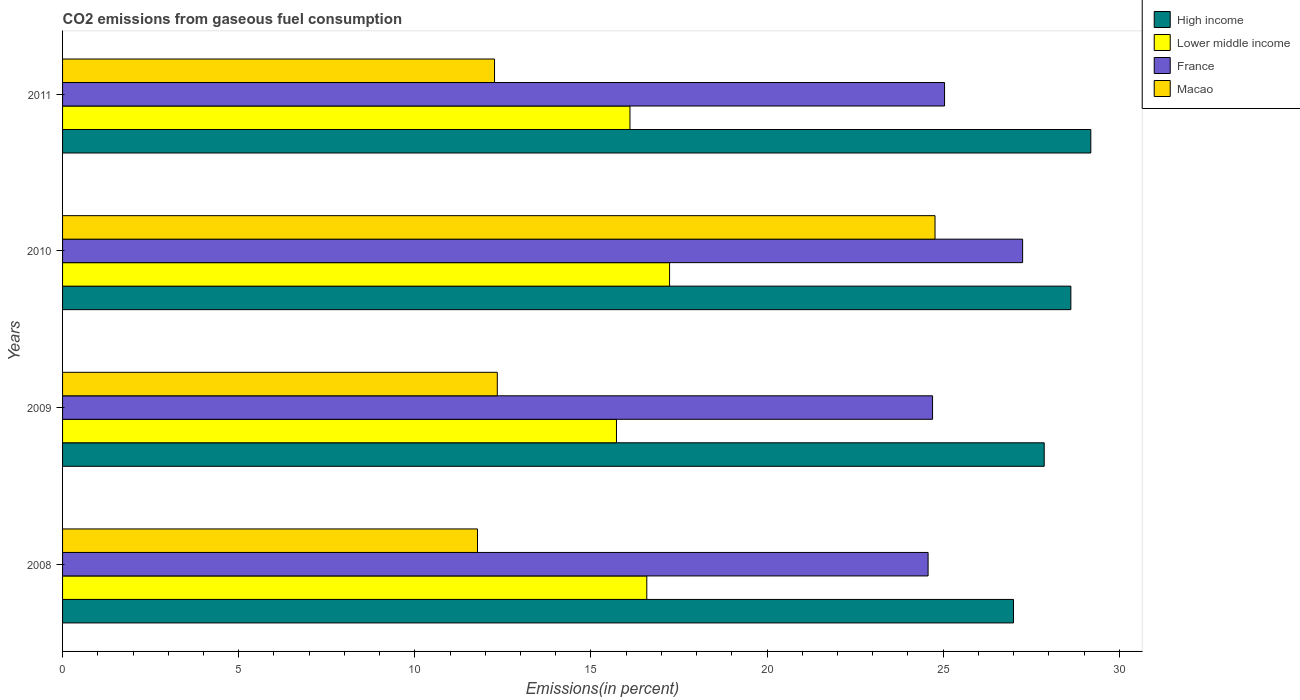How many different coloured bars are there?
Ensure brevity in your answer.  4. How many groups of bars are there?
Provide a succinct answer. 4. Are the number of bars on each tick of the Y-axis equal?
Your response must be concise. Yes. How many bars are there on the 1st tick from the bottom?
Your response must be concise. 4. What is the total CO2 emitted in Lower middle income in 2011?
Ensure brevity in your answer.  16.11. Across all years, what is the maximum total CO2 emitted in France?
Provide a succinct answer. 27.26. Across all years, what is the minimum total CO2 emitted in Lower middle income?
Your answer should be very brief. 15.73. In which year was the total CO2 emitted in High income maximum?
Provide a short and direct response. 2011. In which year was the total CO2 emitted in France minimum?
Make the answer very short. 2008. What is the total total CO2 emitted in France in the graph?
Make the answer very short. 101.57. What is the difference between the total CO2 emitted in France in 2008 and that in 2011?
Keep it short and to the point. -0.47. What is the difference between the total CO2 emitted in Macao in 2009 and the total CO2 emitted in Lower middle income in 2008?
Give a very brief answer. -4.24. What is the average total CO2 emitted in Macao per year?
Your answer should be compact. 15.29. In the year 2008, what is the difference between the total CO2 emitted in France and total CO2 emitted in Lower middle income?
Your answer should be very brief. 7.99. What is the ratio of the total CO2 emitted in Macao in 2010 to that in 2011?
Ensure brevity in your answer.  2.02. Is the total CO2 emitted in Macao in 2009 less than that in 2010?
Provide a short and direct response. Yes. Is the difference between the total CO2 emitted in France in 2009 and 2011 greater than the difference between the total CO2 emitted in Lower middle income in 2009 and 2011?
Your answer should be very brief. Yes. What is the difference between the highest and the second highest total CO2 emitted in Lower middle income?
Provide a succinct answer. 0.65. What is the difference between the highest and the lowest total CO2 emitted in Lower middle income?
Offer a very short reply. 1.51. In how many years, is the total CO2 emitted in High income greater than the average total CO2 emitted in High income taken over all years?
Offer a very short reply. 2. Is it the case that in every year, the sum of the total CO2 emitted in High income and total CO2 emitted in Macao is greater than the sum of total CO2 emitted in France and total CO2 emitted in Lower middle income?
Your response must be concise. Yes. What does the 2nd bar from the top in 2008 represents?
Your answer should be compact. France. What does the 1st bar from the bottom in 2011 represents?
Offer a very short reply. High income. How many bars are there?
Provide a short and direct response. 16. Are all the bars in the graph horizontal?
Keep it short and to the point. Yes. Does the graph contain any zero values?
Provide a short and direct response. No. Does the graph contain grids?
Your answer should be compact. No. Where does the legend appear in the graph?
Provide a short and direct response. Top right. How are the legend labels stacked?
Offer a very short reply. Vertical. What is the title of the graph?
Offer a very short reply. CO2 emissions from gaseous fuel consumption. Does "Georgia" appear as one of the legend labels in the graph?
Your answer should be very brief. No. What is the label or title of the X-axis?
Your answer should be compact. Emissions(in percent). What is the Emissions(in percent) in High income in 2008?
Ensure brevity in your answer.  27. What is the Emissions(in percent) of Lower middle income in 2008?
Ensure brevity in your answer.  16.59. What is the Emissions(in percent) in France in 2008?
Provide a succinct answer. 24.57. What is the Emissions(in percent) of Macao in 2008?
Ensure brevity in your answer.  11.78. What is the Emissions(in percent) of High income in 2009?
Provide a succinct answer. 27.87. What is the Emissions(in percent) of Lower middle income in 2009?
Ensure brevity in your answer.  15.73. What is the Emissions(in percent) of France in 2009?
Your response must be concise. 24.7. What is the Emissions(in percent) in Macao in 2009?
Offer a very short reply. 12.34. What is the Emissions(in percent) of High income in 2010?
Ensure brevity in your answer.  28.63. What is the Emissions(in percent) of Lower middle income in 2010?
Give a very brief answer. 17.23. What is the Emissions(in percent) in France in 2010?
Provide a short and direct response. 27.26. What is the Emissions(in percent) of Macao in 2010?
Ensure brevity in your answer.  24.77. What is the Emissions(in percent) of High income in 2011?
Provide a short and direct response. 29.19. What is the Emissions(in percent) in Lower middle income in 2011?
Your answer should be very brief. 16.11. What is the Emissions(in percent) of France in 2011?
Ensure brevity in your answer.  25.04. What is the Emissions(in percent) of Macao in 2011?
Ensure brevity in your answer.  12.26. Across all years, what is the maximum Emissions(in percent) of High income?
Offer a very short reply. 29.19. Across all years, what is the maximum Emissions(in percent) in Lower middle income?
Provide a succinct answer. 17.23. Across all years, what is the maximum Emissions(in percent) in France?
Your answer should be very brief. 27.26. Across all years, what is the maximum Emissions(in percent) in Macao?
Offer a very short reply. 24.77. Across all years, what is the minimum Emissions(in percent) in High income?
Provide a succinct answer. 27. Across all years, what is the minimum Emissions(in percent) of Lower middle income?
Offer a very short reply. 15.73. Across all years, what is the minimum Emissions(in percent) of France?
Offer a very short reply. 24.57. Across all years, what is the minimum Emissions(in percent) in Macao?
Give a very brief answer. 11.78. What is the total Emissions(in percent) of High income in the graph?
Give a very brief answer. 112.69. What is the total Emissions(in percent) in Lower middle income in the graph?
Provide a short and direct response. 65.66. What is the total Emissions(in percent) of France in the graph?
Offer a terse response. 101.57. What is the total Emissions(in percent) in Macao in the graph?
Offer a terse response. 61.16. What is the difference between the Emissions(in percent) in High income in 2008 and that in 2009?
Your response must be concise. -0.87. What is the difference between the Emissions(in percent) of Lower middle income in 2008 and that in 2009?
Your answer should be very brief. 0.86. What is the difference between the Emissions(in percent) in France in 2008 and that in 2009?
Your answer should be very brief. -0.13. What is the difference between the Emissions(in percent) of Macao in 2008 and that in 2009?
Your answer should be very brief. -0.56. What is the difference between the Emissions(in percent) in High income in 2008 and that in 2010?
Your response must be concise. -1.63. What is the difference between the Emissions(in percent) in Lower middle income in 2008 and that in 2010?
Your answer should be compact. -0.65. What is the difference between the Emissions(in percent) of France in 2008 and that in 2010?
Your answer should be compact. -2.68. What is the difference between the Emissions(in percent) in Macao in 2008 and that in 2010?
Offer a very short reply. -12.99. What is the difference between the Emissions(in percent) of High income in 2008 and that in 2011?
Make the answer very short. -2.19. What is the difference between the Emissions(in percent) in Lower middle income in 2008 and that in 2011?
Provide a succinct answer. 0.48. What is the difference between the Emissions(in percent) in France in 2008 and that in 2011?
Offer a terse response. -0.47. What is the difference between the Emissions(in percent) in Macao in 2008 and that in 2011?
Your answer should be very brief. -0.48. What is the difference between the Emissions(in percent) of High income in 2009 and that in 2010?
Provide a succinct answer. -0.76. What is the difference between the Emissions(in percent) in Lower middle income in 2009 and that in 2010?
Make the answer very short. -1.51. What is the difference between the Emissions(in percent) of France in 2009 and that in 2010?
Give a very brief answer. -2.56. What is the difference between the Emissions(in percent) in Macao in 2009 and that in 2010?
Your answer should be very brief. -12.43. What is the difference between the Emissions(in percent) of High income in 2009 and that in 2011?
Make the answer very short. -1.32. What is the difference between the Emissions(in percent) of Lower middle income in 2009 and that in 2011?
Provide a short and direct response. -0.38. What is the difference between the Emissions(in percent) of France in 2009 and that in 2011?
Your response must be concise. -0.34. What is the difference between the Emissions(in percent) in Macao in 2009 and that in 2011?
Keep it short and to the point. 0.08. What is the difference between the Emissions(in percent) of High income in 2010 and that in 2011?
Offer a terse response. -0.57. What is the difference between the Emissions(in percent) of Lower middle income in 2010 and that in 2011?
Offer a terse response. 1.12. What is the difference between the Emissions(in percent) in France in 2010 and that in 2011?
Your answer should be very brief. 2.22. What is the difference between the Emissions(in percent) of Macao in 2010 and that in 2011?
Provide a short and direct response. 12.51. What is the difference between the Emissions(in percent) of High income in 2008 and the Emissions(in percent) of Lower middle income in 2009?
Offer a very short reply. 11.27. What is the difference between the Emissions(in percent) of High income in 2008 and the Emissions(in percent) of France in 2009?
Your response must be concise. 2.3. What is the difference between the Emissions(in percent) of High income in 2008 and the Emissions(in percent) of Macao in 2009?
Make the answer very short. 14.66. What is the difference between the Emissions(in percent) in Lower middle income in 2008 and the Emissions(in percent) in France in 2009?
Your answer should be compact. -8.11. What is the difference between the Emissions(in percent) in Lower middle income in 2008 and the Emissions(in percent) in Macao in 2009?
Provide a short and direct response. 4.24. What is the difference between the Emissions(in percent) in France in 2008 and the Emissions(in percent) in Macao in 2009?
Make the answer very short. 12.23. What is the difference between the Emissions(in percent) of High income in 2008 and the Emissions(in percent) of Lower middle income in 2010?
Your answer should be very brief. 9.76. What is the difference between the Emissions(in percent) of High income in 2008 and the Emissions(in percent) of France in 2010?
Provide a succinct answer. -0.26. What is the difference between the Emissions(in percent) in High income in 2008 and the Emissions(in percent) in Macao in 2010?
Offer a very short reply. 2.23. What is the difference between the Emissions(in percent) in Lower middle income in 2008 and the Emissions(in percent) in France in 2010?
Make the answer very short. -10.67. What is the difference between the Emissions(in percent) in Lower middle income in 2008 and the Emissions(in percent) in Macao in 2010?
Provide a succinct answer. -8.18. What is the difference between the Emissions(in percent) in France in 2008 and the Emissions(in percent) in Macao in 2010?
Give a very brief answer. -0.2. What is the difference between the Emissions(in percent) of High income in 2008 and the Emissions(in percent) of Lower middle income in 2011?
Ensure brevity in your answer.  10.89. What is the difference between the Emissions(in percent) of High income in 2008 and the Emissions(in percent) of France in 2011?
Offer a terse response. 1.96. What is the difference between the Emissions(in percent) in High income in 2008 and the Emissions(in percent) in Macao in 2011?
Provide a short and direct response. 14.73. What is the difference between the Emissions(in percent) of Lower middle income in 2008 and the Emissions(in percent) of France in 2011?
Provide a succinct answer. -8.45. What is the difference between the Emissions(in percent) in Lower middle income in 2008 and the Emissions(in percent) in Macao in 2011?
Offer a very short reply. 4.32. What is the difference between the Emissions(in percent) of France in 2008 and the Emissions(in percent) of Macao in 2011?
Provide a succinct answer. 12.31. What is the difference between the Emissions(in percent) in High income in 2009 and the Emissions(in percent) in Lower middle income in 2010?
Ensure brevity in your answer.  10.64. What is the difference between the Emissions(in percent) of High income in 2009 and the Emissions(in percent) of France in 2010?
Make the answer very short. 0.61. What is the difference between the Emissions(in percent) of High income in 2009 and the Emissions(in percent) of Macao in 2010?
Provide a succinct answer. 3.1. What is the difference between the Emissions(in percent) of Lower middle income in 2009 and the Emissions(in percent) of France in 2010?
Provide a succinct answer. -11.53. What is the difference between the Emissions(in percent) in Lower middle income in 2009 and the Emissions(in percent) in Macao in 2010?
Give a very brief answer. -9.04. What is the difference between the Emissions(in percent) in France in 2009 and the Emissions(in percent) in Macao in 2010?
Your answer should be very brief. -0.07. What is the difference between the Emissions(in percent) of High income in 2009 and the Emissions(in percent) of Lower middle income in 2011?
Offer a very short reply. 11.76. What is the difference between the Emissions(in percent) of High income in 2009 and the Emissions(in percent) of France in 2011?
Provide a short and direct response. 2.83. What is the difference between the Emissions(in percent) of High income in 2009 and the Emissions(in percent) of Macao in 2011?
Give a very brief answer. 15.61. What is the difference between the Emissions(in percent) of Lower middle income in 2009 and the Emissions(in percent) of France in 2011?
Provide a short and direct response. -9.31. What is the difference between the Emissions(in percent) in Lower middle income in 2009 and the Emissions(in percent) in Macao in 2011?
Offer a terse response. 3.46. What is the difference between the Emissions(in percent) in France in 2009 and the Emissions(in percent) in Macao in 2011?
Provide a succinct answer. 12.44. What is the difference between the Emissions(in percent) in High income in 2010 and the Emissions(in percent) in Lower middle income in 2011?
Your answer should be compact. 12.52. What is the difference between the Emissions(in percent) of High income in 2010 and the Emissions(in percent) of France in 2011?
Provide a short and direct response. 3.59. What is the difference between the Emissions(in percent) in High income in 2010 and the Emissions(in percent) in Macao in 2011?
Ensure brevity in your answer.  16.36. What is the difference between the Emissions(in percent) in Lower middle income in 2010 and the Emissions(in percent) in France in 2011?
Ensure brevity in your answer.  -7.81. What is the difference between the Emissions(in percent) of Lower middle income in 2010 and the Emissions(in percent) of Macao in 2011?
Your response must be concise. 4.97. What is the difference between the Emissions(in percent) in France in 2010 and the Emissions(in percent) in Macao in 2011?
Give a very brief answer. 14.99. What is the average Emissions(in percent) of High income per year?
Offer a very short reply. 28.17. What is the average Emissions(in percent) in Lower middle income per year?
Your answer should be very brief. 16.41. What is the average Emissions(in percent) in France per year?
Make the answer very short. 25.39. What is the average Emissions(in percent) in Macao per year?
Keep it short and to the point. 15.29. In the year 2008, what is the difference between the Emissions(in percent) in High income and Emissions(in percent) in Lower middle income?
Give a very brief answer. 10.41. In the year 2008, what is the difference between the Emissions(in percent) in High income and Emissions(in percent) in France?
Make the answer very short. 2.42. In the year 2008, what is the difference between the Emissions(in percent) in High income and Emissions(in percent) in Macao?
Make the answer very short. 15.22. In the year 2008, what is the difference between the Emissions(in percent) in Lower middle income and Emissions(in percent) in France?
Your response must be concise. -7.99. In the year 2008, what is the difference between the Emissions(in percent) of Lower middle income and Emissions(in percent) of Macao?
Provide a short and direct response. 4.81. In the year 2008, what is the difference between the Emissions(in percent) of France and Emissions(in percent) of Macao?
Give a very brief answer. 12.79. In the year 2009, what is the difference between the Emissions(in percent) of High income and Emissions(in percent) of Lower middle income?
Keep it short and to the point. 12.14. In the year 2009, what is the difference between the Emissions(in percent) of High income and Emissions(in percent) of France?
Give a very brief answer. 3.17. In the year 2009, what is the difference between the Emissions(in percent) of High income and Emissions(in percent) of Macao?
Your answer should be very brief. 15.53. In the year 2009, what is the difference between the Emissions(in percent) in Lower middle income and Emissions(in percent) in France?
Provide a succinct answer. -8.97. In the year 2009, what is the difference between the Emissions(in percent) in Lower middle income and Emissions(in percent) in Macao?
Provide a short and direct response. 3.38. In the year 2009, what is the difference between the Emissions(in percent) in France and Emissions(in percent) in Macao?
Make the answer very short. 12.36. In the year 2010, what is the difference between the Emissions(in percent) in High income and Emissions(in percent) in Lower middle income?
Offer a terse response. 11.39. In the year 2010, what is the difference between the Emissions(in percent) in High income and Emissions(in percent) in France?
Your response must be concise. 1.37. In the year 2010, what is the difference between the Emissions(in percent) of High income and Emissions(in percent) of Macao?
Offer a terse response. 3.86. In the year 2010, what is the difference between the Emissions(in percent) in Lower middle income and Emissions(in percent) in France?
Ensure brevity in your answer.  -10.02. In the year 2010, what is the difference between the Emissions(in percent) of Lower middle income and Emissions(in percent) of Macao?
Give a very brief answer. -7.54. In the year 2010, what is the difference between the Emissions(in percent) in France and Emissions(in percent) in Macao?
Your answer should be compact. 2.49. In the year 2011, what is the difference between the Emissions(in percent) of High income and Emissions(in percent) of Lower middle income?
Provide a short and direct response. 13.08. In the year 2011, what is the difference between the Emissions(in percent) of High income and Emissions(in percent) of France?
Your answer should be compact. 4.15. In the year 2011, what is the difference between the Emissions(in percent) in High income and Emissions(in percent) in Macao?
Offer a very short reply. 16.93. In the year 2011, what is the difference between the Emissions(in percent) of Lower middle income and Emissions(in percent) of France?
Provide a short and direct response. -8.93. In the year 2011, what is the difference between the Emissions(in percent) in Lower middle income and Emissions(in percent) in Macao?
Your answer should be very brief. 3.85. In the year 2011, what is the difference between the Emissions(in percent) of France and Emissions(in percent) of Macao?
Offer a terse response. 12.78. What is the ratio of the Emissions(in percent) in High income in 2008 to that in 2009?
Your response must be concise. 0.97. What is the ratio of the Emissions(in percent) of Lower middle income in 2008 to that in 2009?
Offer a very short reply. 1.05. What is the ratio of the Emissions(in percent) of France in 2008 to that in 2009?
Your answer should be very brief. 0.99. What is the ratio of the Emissions(in percent) of Macao in 2008 to that in 2009?
Provide a short and direct response. 0.95. What is the ratio of the Emissions(in percent) in High income in 2008 to that in 2010?
Give a very brief answer. 0.94. What is the ratio of the Emissions(in percent) of Lower middle income in 2008 to that in 2010?
Offer a very short reply. 0.96. What is the ratio of the Emissions(in percent) of France in 2008 to that in 2010?
Ensure brevity in your answer.  0.9. What is the ratio of the Emissions(in percent) in Macao in 2008 to that in 2010?
Offer a terse response. 0.48. What is the ratio of the Emissions(in percent) of High income in 2008 to that in 2011?
Your answer should be very brief. 0.92. What is the ratio of the Emissions(in percent) in Lower middle income in 2008 to that in 2011?
Ensure brevity in your answer.  1.03. What is the ratio of the Emissions(in percent) in France in 2008 to that in 2011?
Keep it short and to the point. 0.98. What is the ratio of the Emissions(in percent) of Macao in 2008 to that in 2011?
Your answer should be very brief. 0.96. What is the ratio of the Emissions(in percent) of High income in 2009 to that in 2010?
Ensure brevity in your answer.  0.97. What is the ratio of the Emissions(in percent) in Lower middle income in 2009 to that in 2010?
Give a very brief answer. 0.91. What is the ratio of the Emissions(in percent) in France in 2009 to that in 2010?
Provide a succinct answer. 0.91. What is the ratio of the Emissions(in percent) of Macao in 2009 to that in 2010?
Offer a terse response. 0.5. What is the ratio of the Emissions(in percent) of High income in 2009 to that in 2011?
Your answer should be very brief. 0.95. What is the ratio of the Emissions(in percent) of Lower middle income in 2009 to that in 2011?
Keep it short and to the point. 0.98. What is the ratio of the Emissions(in percent) in France in 2009 to that in 2011?
Offer a terse response. 0.99. What is the ratio of the Emissions(in percent) in Macao in 2009 to that in 2011?
Provide a short and direct response. 1.01. What is the ratio of the Emissions(in percent) in High income in 2010 to that in 2011?
Give a very brief answer. 0.98. What is the ratio of the Emissions(in percent) in Lower middle income in 2010 to that in 2011?
Keep it short and to the point. 1.07. What is the ratio of the Emissions(in percent) in France in 2010 to that in 2011?
Keep it short and to the point. 1.09. What is the ratio of the Emissions(in percent) of Macao in 2010 to that in 2011?
Your answer should be very brief. 2.02. What is the difference between the highest and the second highest Emissions(in percent) of High income?
Give a very brief answer. 0.57. What is the difference between the highest and the second highest Emissions(in percent) in Lower middle income?
Offer a terse response. 0.65. What is the difference between the highest and the second highest Emissions(in percent) in France?
Your answer should be very brief. 2.22. What is the difference between the highest and the second highest Emissions(in percent) of Macao?
Your answer should be very brief. 12.43. What is the difference between the highest and the lowest Emissions(in percent) in High income?
Make the answer very short. 2.19. What is the difference between the highest and the lowest Emissions(in percent) of Lower middle income?
Your response must be concise. 1.51. What is the difference between the highest and the lowest Emissions(in percent) of France?
Give a very brief answer. 2.68. What is the difference between the highest and the lowest Emissions(in percent) of Macao?
Your response must be concise. 12.99. 